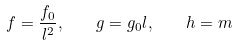Convert formula to latex. <formula><loc_0><loc_0><loc_500><loc_500>f = \frac { f _ { 0 } } { l ^ { 2 } } , \quad g = g _ { 0 } l , \quad h = m</formula> 